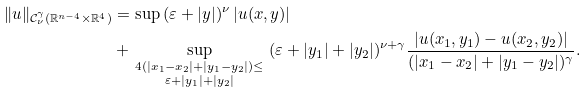Convert formula to latex. <formula><loc_0><loc_0><loc_500><loc_500>\| u \| _ { \mathcal { C } _ { \nu } ^ { \gamma } ( \mathbb { R } ^ { n - 4 } \times \mathbb { R } ^ { 4 } ) } & = \sup \, ( \varepsilon + | y | ) ^ { \nu } \, | u ( x , y ) | \\ & + \sup _ { \begin{smallmatrix} 4 ( | x _ { 1 } - x _ { 2 } | + | y _ { 1 } - y _ { 2 } | ) \leq \\ \varepsilon + | y _ { 1 } | + | y _ { 2 } | \end{smallmatrix} } \, ( \varepsilon + | y _ { 1 } | + | y _ { 2 } | ) ^ { \nu + \gamma } \frac { | u ( x _ { 1 } , y _ { 1 } ) - u ( x _ { 2 } , y _ { 2 } ) | } { ( | x _ { 1 } - x _ { 2 } | + | y _ { 1 } - y _ { 2 } | ) ^ { \gamma } } .</formula> 